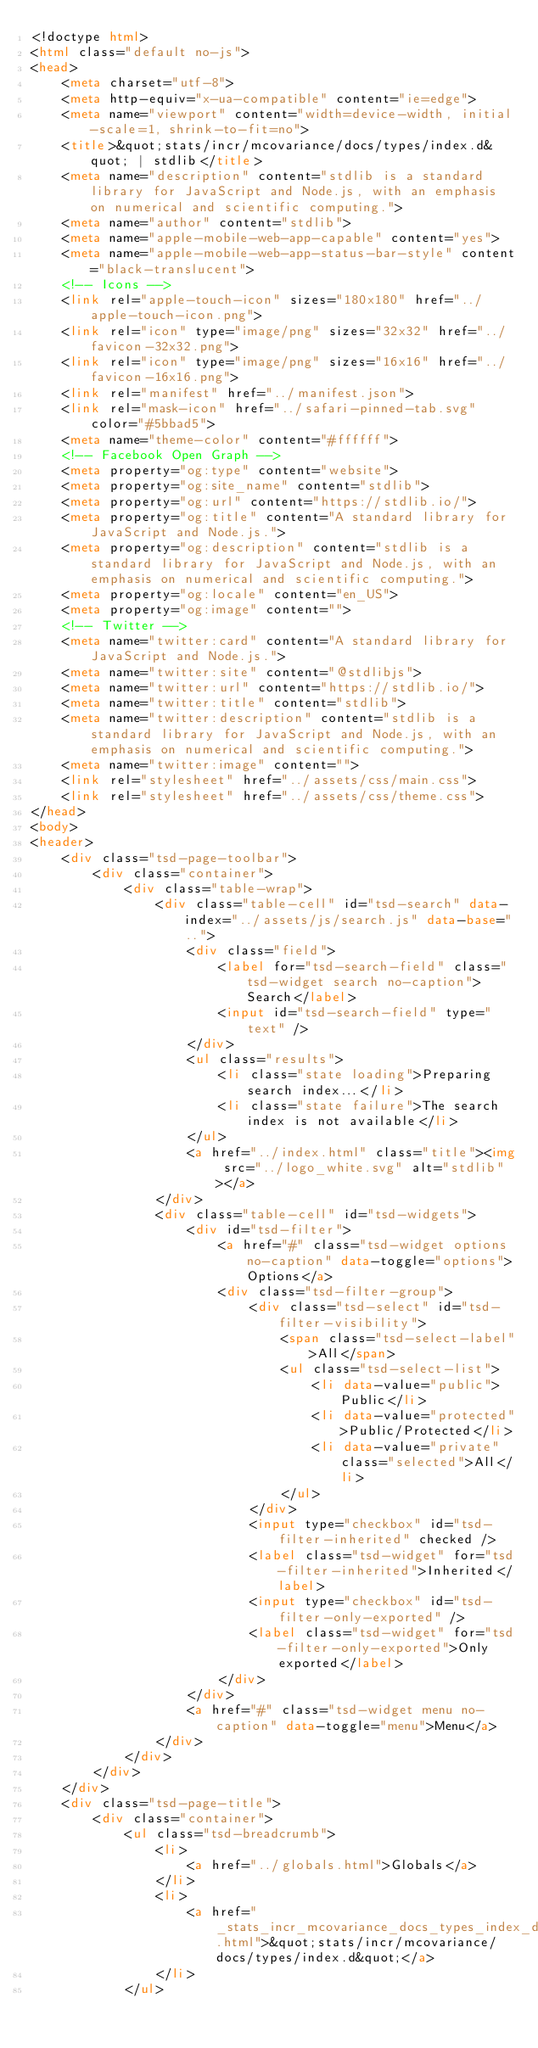Convert code to text. <code><loc_0><loc_0><loc_500><loc_500><_HTML_><!doctype html>
<html class="default no-js">
<head>
	<meta charset="utf-8">
	<meta http-equiv="x-ua-compatible" content="ie=edge">
	<meta name="viewport" content="width=device-width, initial-scale=1, shrink-to-fit=no">
	<title>&quot;stats/incr/mcovariance/docs/types/index.d&quot; | stdlib</title>
	<meta name="description" content="stdlib is a standard library for JavaScript and Node.js, with an emphasis on numerical and scientific computing.">
	<meta name="author" content="stdlib">
	<meta name="apple-mobile-web-app-capable" content="yes">
	<meta name="apple-mobile-web-app-status-bar-style" content="black-translucent">
	<!-- Icons -->
	<link rel="apple-touch-icon" sizes="180x180" href="../apple-touch-icon.png">
	<link rel="icon" type="image/png" sizes="32x32" href="../favicon-32x32.png">
	<link rel="icon" type="image/png" sizes="16x16" href="../favicon-16x16.png">
	<link rel="manifest" href="../manifest.json">
	<link rel="mask-icon" href="../safari-pinned-tab.svg" color="#5bbad5">
	<meta name="theme-color" content="#ffffff">
	<!-- Facebook Open Graph -->
	<meta property="og:type" content="website">
	<meta property="og:site_name" content="stdlib">
	<meta property="og:url" content="https://stdlib.io/">
	<meta property="og:title" content="A standard library for JavaScript and Node.js.">
	<meta property="og:description" content="stdlib is a standard library for JavaScript and Node.js, with an emphasis on numerical and scientific computing.">
	<meta property="og:locale" content="en_US">
	<meta property="og:image" content="">
	<!-- Twitter -->
	<meta name="twitter:card" content="A standard library for JavaScript and Node.js.">
	<meta name="twitter:site" content="@stdlibjs">
	<meta name="twitter:url" content="https://stdlib.io/">
	<meta name="twitter:title" content="stdlib">
	<meta name="twitter:description" content="stdlib is a standard library for JavaScript and Node.js, with an emphasis on numerical and scientific computing.">
	<meta name="twitter:image" content="">
	<link rel="stylesheet" href="../assets/css/main.css">
	<link rel="stylesheet" href="../assets/css/theme.css">
</head>
<body>
<header>
	<div class="tsd-page-toolbar">
		<div class="container">
			<div class="table-wrap">
				<div class="table-cell" id="tsd-search" data-index="../assets/js/search.js" data-base="..">
					<div class="field">
						<label for="tsd-search-field" class="tsd-widget search no-caption">Search</label>
						<input id="tsd-search-field" type="text" />
					</div>
					<ul class="results">
						<li class="state loading">Preparing search index...</li>
						<li class="state failure">The search index is not available</li>
					</ul>
					<a href="../index.html" class="title"><img src="../logo_white.svg" alt="stdlib"></a>
				</div>
				<div class="table-cell" id="tsd-widgets">
					<div id="tsd-filter">
						<a href="#" class="tsd-widget options no-caption" data-toggle="options">Options</a>
						<div class="tsd-filter-group">
							<div class="tsd-select" id="tsd-filter-visibility">
								<span class="tsd-select-label">All</span>
								<ul class="tsd-select-list">
									<li data-value="public">Public</li>
									<li data-value="protected">Public/Protected</li>
									<li data-value="private" class="selected">All</li>
								</ul>
							</div>
							<input type="checkbox" id="tsd-filter-inherited" checked />
							<label class="tsd-widget" for="tsd-filter-inherited">Inherited</label>
							<input type="checkbox" id="tsd-filter-only-exported" />
							<label class="tsd-widget" for="tsd-filter-only-exported">Only exported</label>
						</div>
					</div>
					<a href="#" class="tsd-widget menu no-caption" data-toggle="menu">Menu</a>
				</div>
			</div>
		</div>
	</div>
	<div class="tsd-page-title">
		<div class="container">
			<ul class="tsd-breadcrumb">
				<li>
					<a href="../globals.html">Globals</a>
				</li>
				<li>
					<a href="_stats_incr_mcovariance_docs_types_index_d_.html">&quot;stats/incr/mcovariance/docs/types/index.d&quot;</a>
				</li>
			</ul></code> 